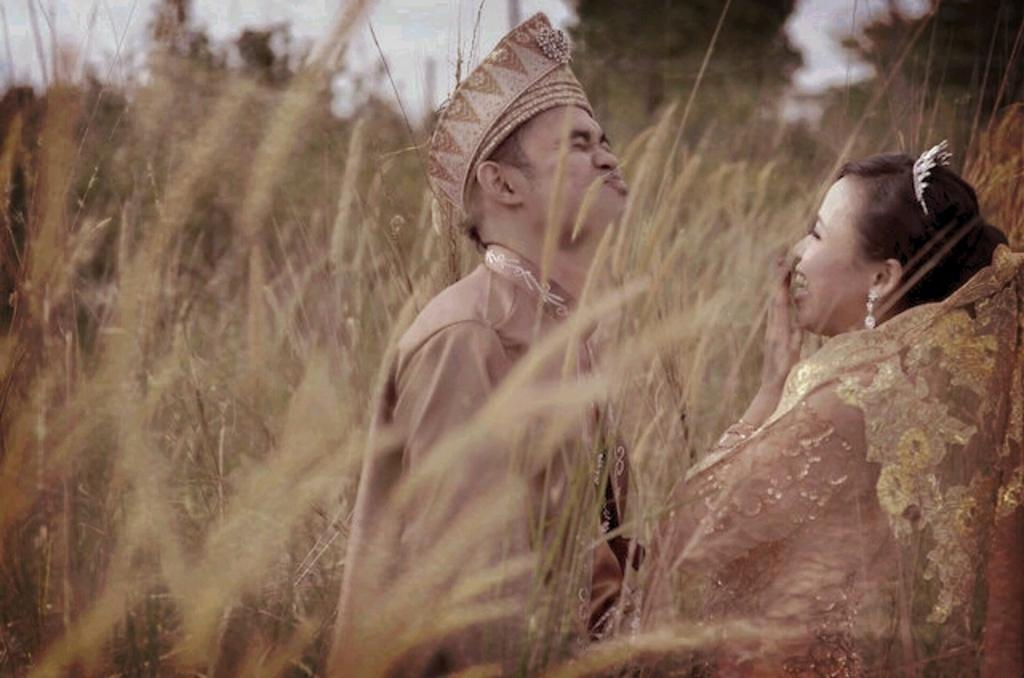How many people are in the image? There are two persons standing in the middle of the image. What are the people doing in the image? The persons are smiling. What type of natural environment is visible in the background? There is grass and trees visible in the background. What is visible at the top of the image? The sky is visible at the top of the image. What type of earth-moving equipment can be seen in the image? There is no earth-moving equipment present in the image. How much profit can be made from the transport business depicted in the image? There is no transport business depicted in the image. 